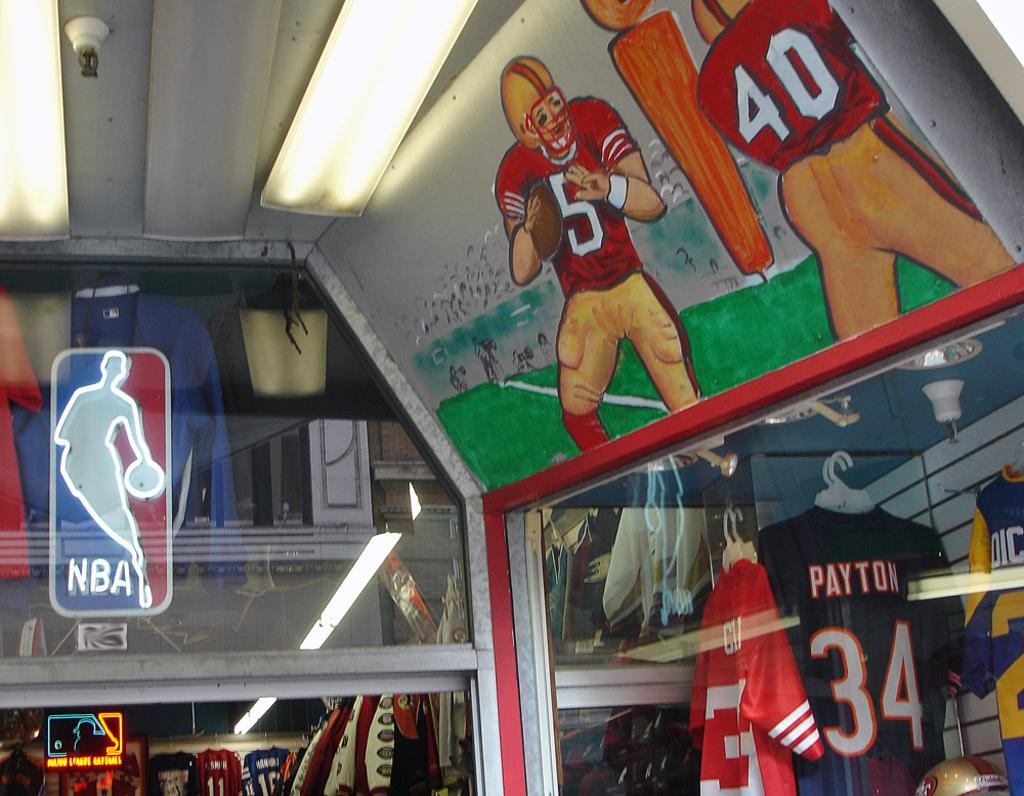<image>
Present a compact description of the photo's key features. Sport Store with basketball and football jerseys, NBA Logo and #5 and # 40 on the top of the image playing football. 